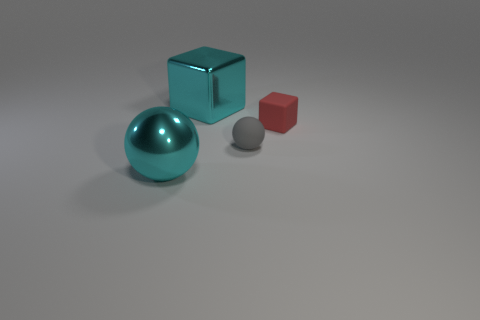There is a big thing that is right of the large cyan metal ball; is its color the same as the ball behind the metallic ball?
Ensure brevity in your answer.  No. How many other things are there of the same material as the small ball?
Provide a succinct answer. 1. There is a object that is both behind the tiny gray matte object and on the right side of the cyan shiny cube; what shape is it?
Your answer should be compact. Cube. Does the small matte sphere have the same color as the big cube behind the tiny block?
Keep it short and to the point. No. There is a cube to the right of the cyan block; does it have the same size as the tiny gray ball?
Keep it short and to the point. Yes. There is a cyan object that is the same shape as the small gray matte thing; what material is it?
Make the answer very short. Metal. Does the small gray object have the same shape as the small red object?
Your answer should be compact. No. What number of objects are in front of the thing to the right of the small ball?
Offer a very short reply. 2. There is a red thing that is the same material as the small gray sphere; what is its shape?
Provide a succinct answer. Cube. How many purple things are either blocks or big metallic blocks?
Keep it short and to the point. 0. 